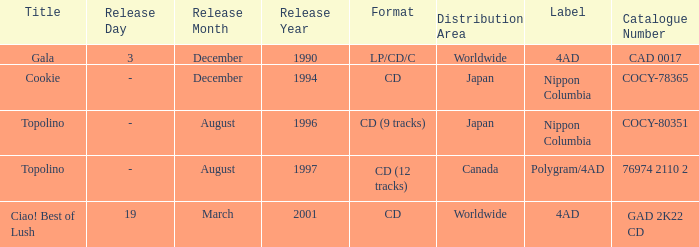What format was released in August 1996? CD (9 tracks). 